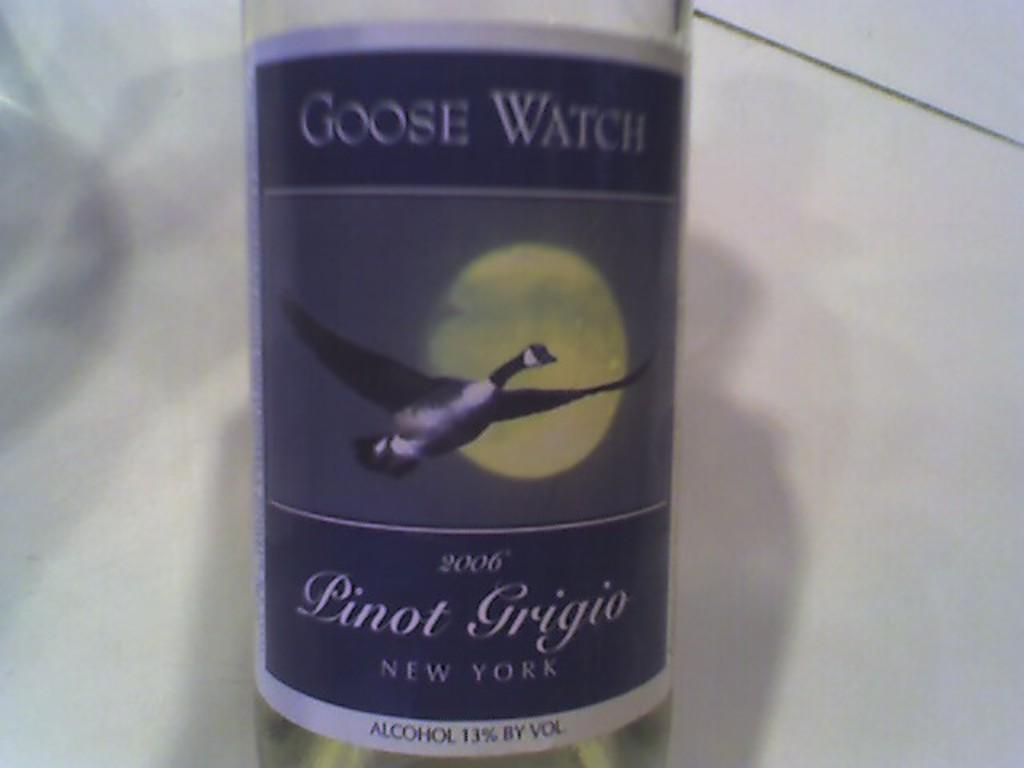What is the main object in the image? There is an alcohol bottle in the image. What type of building can be seen in the background of the image? There is no background or building present in the image; it only features an alcohol bottle. 